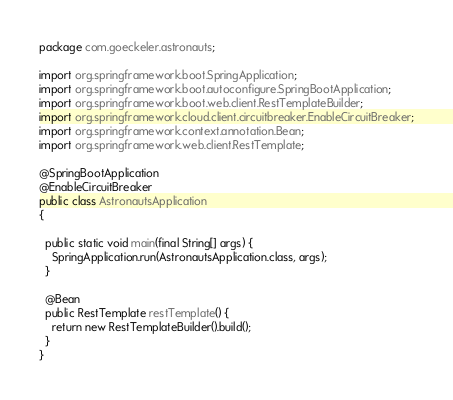Convert code to text. <code><loc_0><loc_0><loc_500><loc_500><_Java_>package com.goeckeler.astronauts;

import org.springframework.boot.SpringApplication;
import org.springframework.boot.autoconfigure.SpringBootApplication;
import org.springframework.boot.web.client.RestTemplateBuilder;
import org.springframework.cloud.client.circuitbreaker.EnableCircuitBreaker;
import org.springframework.context.annotation.Bean;
import org.springframework.web.client.RestTemplate;

@SpringBootApplication
@EnableCircuitBreaker
public class AstronautsApplication
{

  public static void main(final String[] args) {
    SpringApplication.run(AstronautsApplication.class, args);
  }

  @Bean
  public RestTemplate restTemplate() {
    return new RestTemplateBuilder().build();
  }
}
</code> 